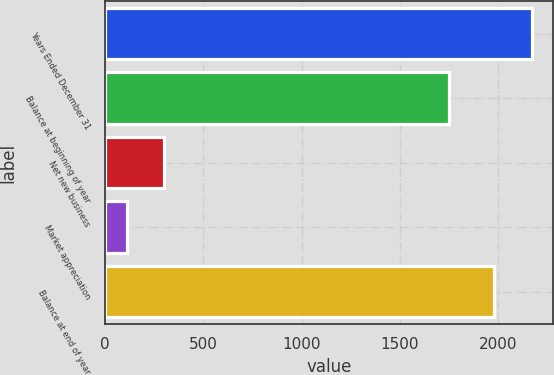Convert chart to OTSL. <chart><loc_0><loc_0><loc_500><loc_500><bar_chart><fcel>Years Ended December 31<fcel>Balance at beginning of year<fcel>Net new business<fcel>Market appreciation<fcel>Balance at end of year<nl><fcel>2168.3<fcel>1749<fcel>303.3<fcel>114<fcel>1979<nl></chart> 